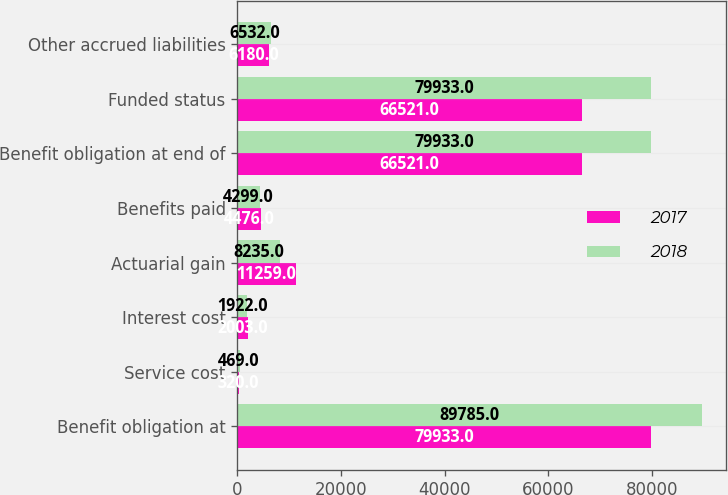<chart> <loc_0><loc_0><loc_500><loc_500><stacked_bar_chart><ecel><fcel>Benefit obligation at<fcel>Service cost<fcel>Interest cost<fcel>Actuarial gain<fcel>Benefits paid<fcel>Benefit obligation at end of<fcel>Funded status<fcel>Other accrued liabilities<nl><fcel>2017<fcel>79933<fcel>320<fcel>2003<fcel>11259<fcel>4476<fcel>66521<fcel>66521<fcel>6180<nl><fcel>2018<fcel>89785<fcel>469<fcel>1922<fcel>8235<fcel>4299<fcel>79933<fcel>79933<fcel>6532<nl></chart> 